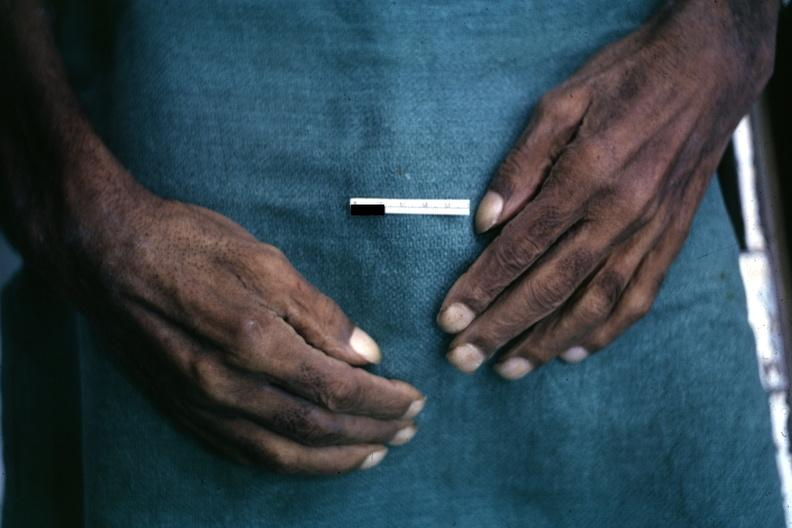does this image show obvious lesion?
Answer the question using a single word or phrase. Yes 